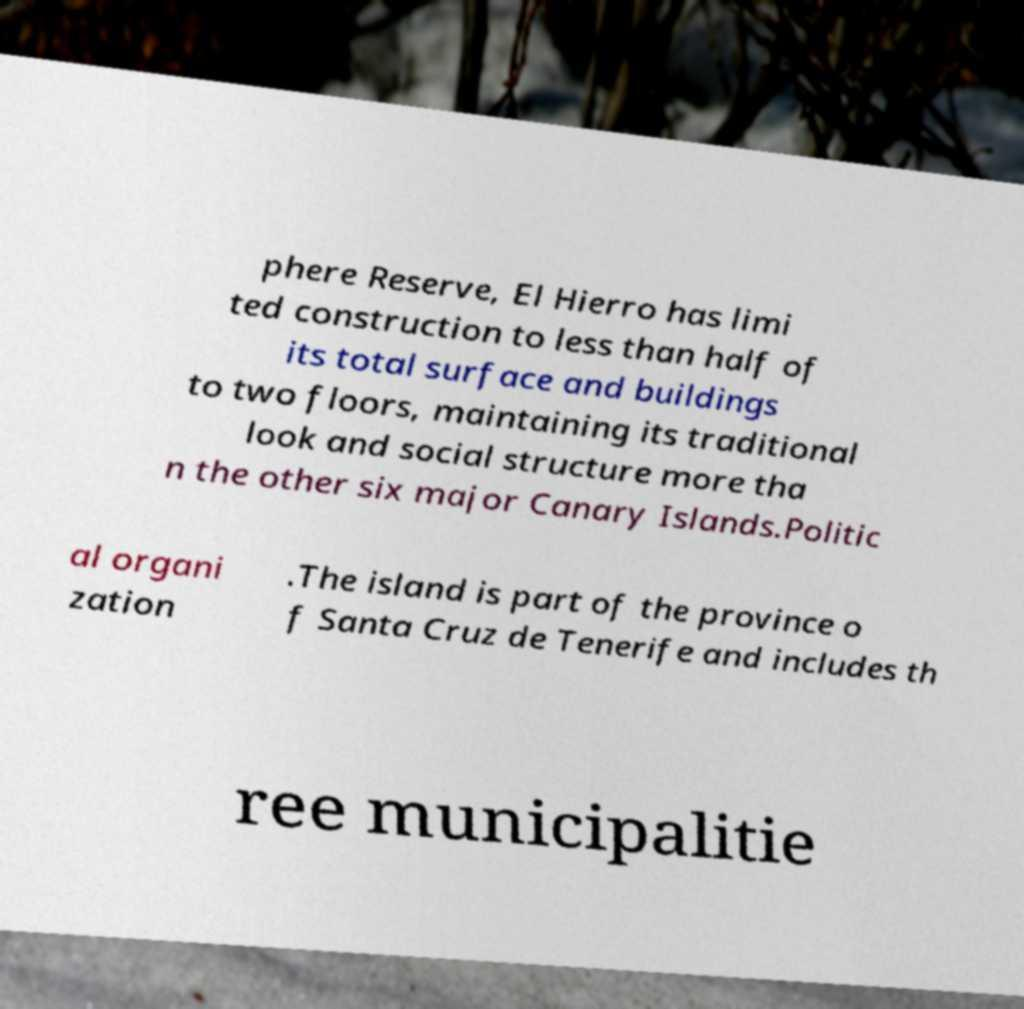I need the written content from this picture converted into text. Can you do that? phere Reserve, El Hierro has limi ted construction to less than half of its total surface and buildings to two floors, maintaining its traditional look and social structure more tha n the other six major Canary Islands.Politic al organi zation .The island is part of the province o f Santa Cruz de Tenerife and includes th ree municipalitie 